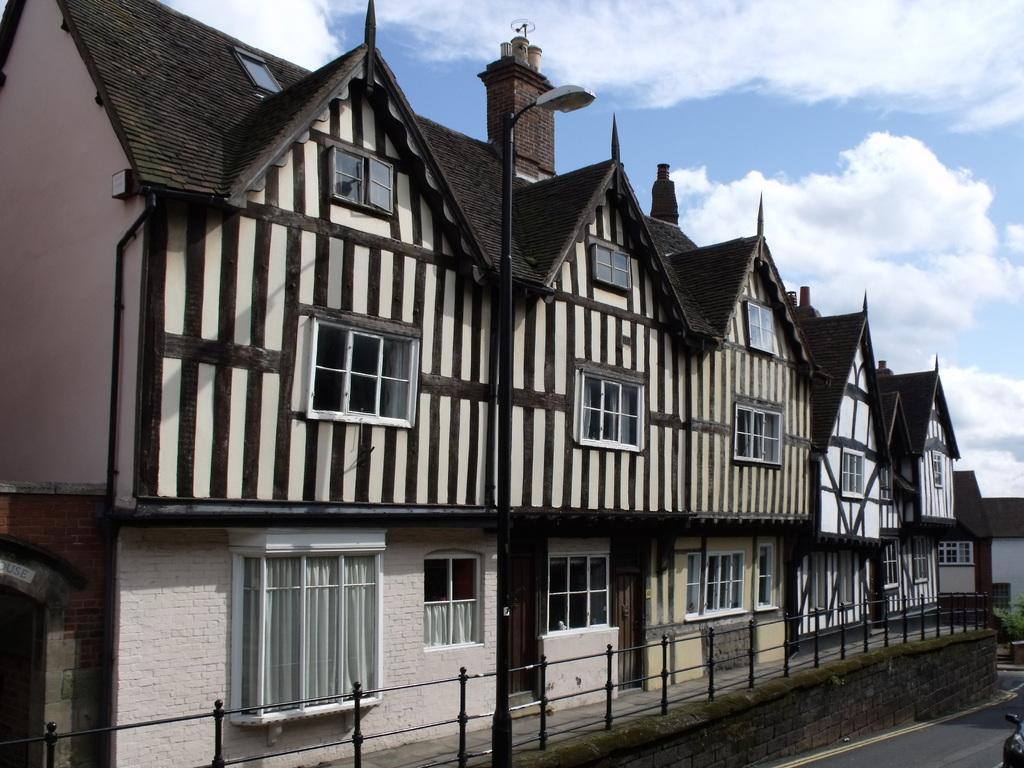Describe this image in one or two sentences. This picture is taken from outside of the building. In this image, we can see a building, glass window, in the glass window, we can see white color curtains. On the right side, we can also see a house, plants, window. In the middle of the image, we can see a street light. At the top, we can see a sky which is a bit cloudy. 